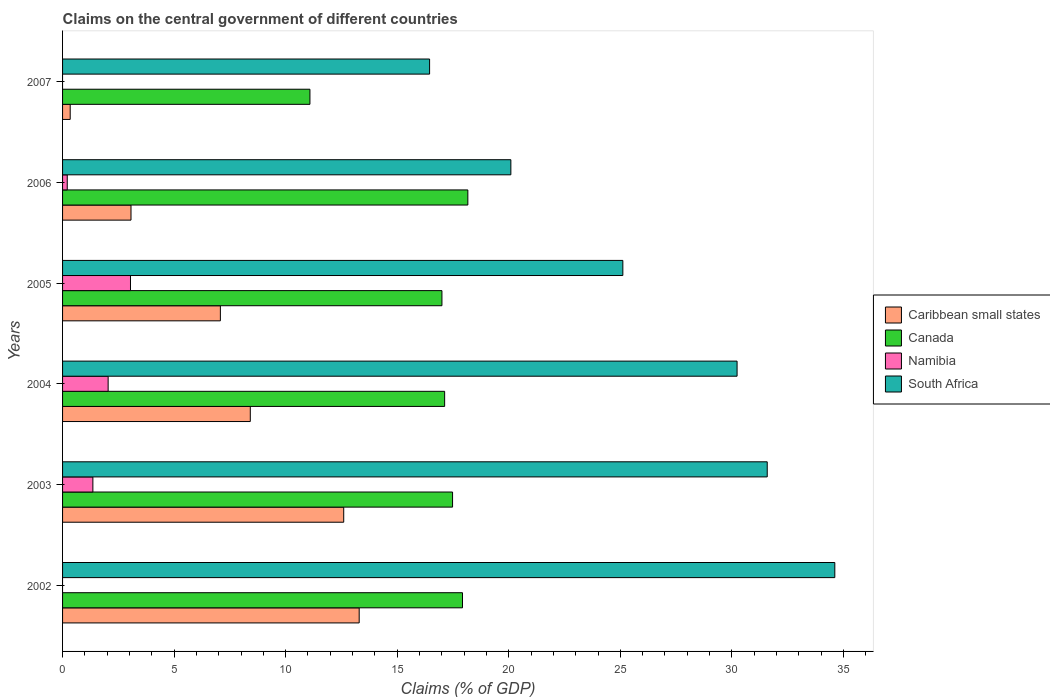Are the number of bars per tick equal to the number of legend labels?
Keep it short and to the point. No. How many bars are there on the 4th tick from the top?
Ensure brevity in your answer.  4. How many bars are there on the 5th tick from the bottom?
Keep it short and to the point. 4. What is the label of the 2nd group of bars from the top?
Offer a terse response. 2006. In how many cases, is the number of bars for a given year not equal to the number of legend labels?
Give a very brief answer. 2. What is the percentage of GDP claimed on the central government in Caribbean small states in 2004?
Keep it short and to the point. 8.41. Across all years, what is the maximum percentage of GDP claimed on the central government in Canada?
Offer a very short reply. 18.17. Across all years, what is the minimum percentage of GDP claimed on the central government in South Africa?
Make the answer very short. 16.45. In which year was the percentage of GDP claimed on the central government in Caribbean small states maximum?
Make the answer very short. 2002. What is the total percentage of GDP claimed on the central government in South Africa in the graph?
Your response must be concise. 158.09. What is the difference between the percentage of GDP claimed on the central government in Caribbean small states in 2004 and that in 2005?
Your answer should be very brief. 1.34. What is the difference between the percentage of GDP claimed on the central government in Namibia in 2005 and the percentage of GDP claimed on the central government in Caribbean small states in 2007?
Give a very brief answer. 2.7. What is the average percentage of GDP claimed on the central government in Namibia per year?
Offer a very short reply. 1.11. In the year 2005, what is the difference between the percentage of GDP claimed on the central government in Namibia and percentage of GDP claimed on the central government in South Africa?
Ensure brevity in your answer.  -22.07. What is the ratio of the percentage of GDP claimed on the central government in South Africa in 2003 to that in 2007?
Provide a short and direct response. 1.92. Is the difference between the percentage of GDP claimed on the central government in Namibia in 2005 and 2006 greater than the difference between the percentage of GDP claimed on the central government in South Africa in 2005 and 2006?
Your answer should be compact. No. What is the difference between the highest and the second highest percentage of GDP claimed on the central government in South Africa?
Make the answer very short. 3.03. What is the difference between the highest and the lowest percentage of GDP claimed on the central government in South Africa?
Give a very brief answer. 18.16. Is it the case that in every year, the sum of the percentage of GDP claimed on the central government in Canada and percentage of GDP claimed on the central government in Namibia is greater than the sum of percentage of GDP claimed on the central government in South Africa and percentage of GDP claimed on the central government in Caribbean small states?
Make the answer very short. No. How many bars are there?
Your answer should be very brief. 22. Does the graph contain any zero values?
Keep it short and to the point. Yes. Does the graph contain grids?
Make the answer very short. No. How many legend labels are there?
Offer a terse response. 4. How are the legend labels stacked?
Provide a succinct answer. Vertical. What is the title of the graph?
Provide a short and direct response. Claims on the central government of different countries. Does "Comoros" appear as one of the legend labels in the graph?
Provide a short and direct response. No. What is the label or title of the X-axis?
Ensure brevity in your answer.  Claims (% of GDP). What is the label or title of the Y-axis?
Offer a terse response. Years. What is the Claims (% of GDP) of Caribbean small states in 2002?
Give a very brief answer. 13.3. What is the Claims (% of GDP) in Canada in 2002?
Make the answer very short. 17.93. What is the Claims (% of GDP) in South Africa in 2002?
Your answer should be very brief. 34.61. What is the Claims (% of GDP) in Caribbean small states in 2003?
Keep it short and to the point. 12.6. What is the Claims (% of GDP) in Canada in 2003?
Your response must be concise. 17.48. What is the Claims (% of GDP) of Namibia in 2003?
Give a very brief answer. 1.36. What is the Claims (% of GDP) in South Africa in 2003?
Give a very brief answer. 31.58. What is the Claims (% of GDP) in Caribbean small states in 2004?
Your answer should be very brief. 8.41. What is the Claims (% of GDP) in Canada in 2004?
Ensure brevity in your answer.  17.13. What is the Claims (% of GDP) of Namibia in 2004?
Make the answer very short. 2.04. What is the Claims (% of GDP) of South Africa in 2004?
Your answer should be compact. 30.23. What is the Claims (% of GDP) of Caribbean small states in 2005?
Provide a short and direct response. 7.07. What is the Claims (% of GDP) of Canada in 2005?
Make the answer very short. 17. What is the Claims (% of GDP) of Namibia in 2005?
Your response must be concise. 3.04. What is the Claims (% of GDP) in South Africa in 2005?
Your answer should be compact. 25.11. What is the Claims (% of GDP) of Caribbean small states in 2006?
Ensure brevity in your answer.  3.07. What is the Claims (% of GDP) in Canada in 2006?
Keep it short and to the point. 18.17. What is the Claims (% of GDP) in Namibia in 2006?
Provide a succinct answer. 0.21. What is the Claims (% of GDP) in South Africa in 2006?
Offer a terse response. 20.09. What is the Claims (% of GDP) in Caribbean small states in 2007?
Give a very brief answer. 0.34. What is the Claims (% of GDP) of Canada in 2007?
Your answer should be compact. 11.09. What is the Claims (% of GDP) of Namibia in 2007?
Your response must be concise. 0. What is the Claims (% of GDP) in South Africa in 2007?
Offer a terse response. 16.45. Across all years, what is the maximum Claims (% of GDP) of Caribbean small states?
Offer a terse response. 13.3. Across all years, what is the maximum Claims (% of GDP) in Canada?
Offer a terse response. 18.17. Across all years, what is the maximum Claims (% of GDP) of Namibia?
Ensure brevity in your answer.  3.04. Across all years, what is the maximum Claims (% of GDP) of South Africa?
Provide a succinct answer. 34.61. Across all years, what is the minimum Claims (% of GDP) of Caribbean small states?
Provide a short and direct response. 0.34. Across all years, what is the minimum Claims (% of GDP) in Canada?
Give a very brief answer. 11.09. Across all years, what is the minimum Claims (% of GDP) in Namibia?
Keep it short and to the point. 0. Across all years, what is the minimum Claims (% of GDP) of South Africa?
Ensure brevity in your answer.  16.45. What is the total Claims (% of GDP) in Caribbean small states in the graph?
Ensure brevity in your answer.  44.79. What is the total Claims (% of GDP) in Canada in the graph?
Give a very brief answer. 98.79. What is the total Claims (% of GDP) in Namibia in the graph?
Keep it short and to the point. 6.65. What is the total Claims (% of GDP) of South Africa in the graph?
Give a very brief answer. 158.09. What is the difference between the Claims (% of GDP) in Caribbean small states in 2002 and that in 2003?
Make the answer very short. 0.69. What is the difference between the Claims (% of GDP) in Canada in 2002 and that in 2003?
Give a very brief answer. 0.45. What is the difference between the Claims (% of GDP) of South Africa in 2002 and that in 2003?
Your answer should be compact. 3.03. What is the difference between the Claims (% of GDP) of Caribbean small states in 2002 and that in 2004?
Your response must be concise. 4.88. What is the difference between the Claims (% of GDP) of Canada in 2002 and that in 2004?
Your answer should be compact. 0.8. What is the difference between the Claims (% of GDP) of South Africa in 2002 and that in 2004?
Offer a terse response. 4.38. What is the difference between the Claims (% of GDP) of Caribbean small states in 2002 and that in 2005?
Your response must be concise. 6.22. What is the difference between the Claims (% of GDP) in Canada in 2002 and that in 2005?
Offer a very short reply. 0.92. What is the difference between the Claims (% of GDP) in South Africa in 2002 and that in 2005?
Offer a terse response. 9.5. What is the difference between the Claims (% of GDP) in Caribbean small states in 2002 and that in 2006?
Offer a very short reply. 10.23. What is the difference between the Claims (% of GDP) of Canada in 2002 and that in 2006?
Offer a very short reply. -0.24. What is the difference between the Claims (% of GDP) in South Africa in 2002 and that in 2006?
Make the answer very short. 14.52. What is the difference between the Claims (% of GDP) of Caribbean small states in 2002 and that in 2007?
Offer a terse response. 12.95. What is the difference between the Claims (% of GDP) in Canada in 2002 and that in 2007?
Provide a succinct answer. 6.84. What is the difference between the Claims (% of GDP) in South Africa in 2002 and that in 2007?
Your response must be concise. 18.16. What is the difference between the Claims (% of GDP) in Caribbean small states in 2003 and that in 2004?
Give a very brief answer. 4.19. What is the difference between the Claims (% of GDP) of Canada in 2003 and that in 2004?
Give a very brief answer. 0.36. What is the difference between the Claims (% of GDP) of Namibia in 2003 and that in 2004?
Ensure brevity in your answer.  -0.68. What is the difference between the Claims (% of GDP) in South Africa in 2003 and that in 2004?
Provide a succinct answer. 1.35. What is the difference between the Claims (% of GDP) in Caribbean small states in 2003 and that in 2005?
Ensure brevity in your answer.  5.53. What is the difference between the Claims (% of GDP) of Canada in 2003 and that in 2005?
Your response must be concise. 0.48. What is the difference between the Claims (% of GDP) in Namibia in 2003 and that in 2005?
Offer a terse response. -1.69. What is the difference between the Claims (% of GDP) of South Africa in 2003 and that in 2005?
Provide a short and direct response. 6.47. What is the difference between the Claims (% of GDP) in Caribbean small states in 2003 and that in 2006?
Offer a terse response. 9.53. What is the difference between the Claims (% of GDP) of Canada in 2003 and that in 2006?
Give a very brief answer. -0.68. What is the difference between the Claims (% of GDP) of Namibia in 2003 and that in 2006?
Provide a succinct answer. 1.15. What is the difference between the Claims (% of GDP) of South Africa in 2003 and that in 2006?
Offer a terse response. 11.49. What is the difference between the Claims (% of GDP) of Caribbean small states in 2003 and that in 2007?
Provide a succinct answer. 12.26. What is the difference between the Claims (% of GDP) of Canada in 2003 and that in 2007?
Offer a very short reply. 6.39. What is the difference between the Claims (% of GDP) of South Africa in 2003 and that in 2007?
Your answer should be compact. 15.13. What is the difference between the Claims (% of GDP) in Caribbean small states in 2004 and that in 2005?
Make the answer very short. 1.34. What is the difference between the Claims (% of GDP) in Canada in 2004 and that in 2005?
Keep it short and to the point. 0.12. What is the difference between the Claims (% of GDP) of Namibia in 2004 and that in 2005?
Make the answer very short. -1. What is the difference between the Claims (% of GDP) of South Africa in 2004 and that in 2005?
Keep it short and to the point. 5.12. What is the difference between the Claims (% of GDP) in Caribbean small states in 2004 and that in 2006?
Ensure brevity in your answer.  5.35. What is the difference between the Claims (% of GDP) of Canada in 2004 and that in 2006?
Provide a succinct answer. -1.04. What is the difference between the Claims (% of GDP) in Namibia in 2004 and that in 2006?
Keep it short and to the point. 1.83. What is the difference between the Claims (% of GDP) of South Africa in 2004 and that in 2006?
Give a very brief answer. 10.14. What is the difference between the Claims (% of GDP) in Caribbean small states in 2004 and that in 2007?
Make the answer very short. 8.07. What is the difference between the Claims (% of GDP) of Canada in 2004 and that in 2007?
Your answer should be very brief. 6.04. What is the difference between the Claims (% of GDP) in South Africa in 2004 and that in 2007?
Your answer should be very brief. 13.78. What is the difference between the Claims (% of GDP) in Caribbean small states in 2005 and that in 2006?
Provide a succinct answer. 4.01. What is the difference between the Claims (% of GDP) in Canada in 2005 and that in 2006?
Ensure brevity in your answer.  -1.16. What is the difference between the Claims (% of GDP) in Namibia in 2005 and that in 2006?
Make the answer very short. 2.83. What is the difference between the Claims (% of GDP) in South Africa in 2005 and that in 2006?
Give a very brief answer. 5.02. What is the difference between the Claims (% of GDP) in Caribbean small states in 2005 and that in 2007?
Your answer should be very brief. 6.73. What is the difference between the Claims (% of GDP) of Canada in 2005 and that in 2007?
Give a very brief answer. 5.92. What is the difference between the Claims (% of GDP) of South Africa in 2005 and that in 2007?
Your response must be concise. 8.66. What is the difference between the Claims (% of GDP) in Caribbean small states in 2006 and that in 2007?
Ensure brevity in your answer.  2.73. What is the difference between the Claims (% of GDP) of Canada in 2006 and that in 2007?
Your answer should be compact. 7.08. What is the difference between the Claims (% of GDP) in South Africa in 2006 and that in 2007?
Make the answer very short. 3.64. What is the difference between the Claims (% of GDP) of Caribbean small states in 2002 and the Claims (% of GDP) of Canada in 2003?
Your response must be concise. -4.19. What is the difference between the Claims (% of GDP) in Caribbean small states in 2002 and the Claims (% of GDP) in Namibia in 2003?
Give a very brief answer. 11.94. What is the difference between the Claims (% of GDP) in Caribbean small states in 2002 and the Claims (% of GDP) in South Africa in 2003?
Keep it short and to the point. -18.29. What is the difference between the Claims (% of GDP) in Canada in 2002 and the Claims (% of GDP) in Namibia in 2003?
Keep it short and to the point. 16.57. What is the difference between the Claims (% of GDP) of Canada in 2002 and the Claims (% of GDP) of South Africa in 2003?
Your answer should be compact. -13.66. What is the difference between the Claims (% of GDP) in Caribbean small states in 2002 and the Claims (% of GDP) in Canada in 2004?
Ensure brevity in your answer.  -3.83. What is the difference between the Claims (% of GDP) of Caribbean small states in 2002 and the Claims (% of GDP) of Namibia in 2004?
Keep it short and to the point. 11.25. What is the difference between the Claims (% of GDP) of Caribbean small states in 2002 and the Claims (% of GDP) of South Africa in 2004?
Make the answer very short. -16.94. What is the difference between the Claims (% of GDP) in Canada in 2002 and the Claims (% of GDP) in Namibia in 2004?
Your answer should be very brief. 15.88. What is the difference between the Claims (% of GDP) in Canada in 2002 and the Claims (% of GDP) in South Africa in 2004?
Your answer should be very brief. -12.31. What is the difference between the Claims (% of GDP) in Caribbean small states in 2002 and the Claims (% of GDP) in Canada in 2005?
Provide a succinct answer. -3.71. What is the difference between the Claims (% of GDP) of Caribbean small states in 2002 and the Claims (% of GDP) of Namibia in 2005?
Provide a succinct answer. 10.25. What is the difference between the Claims (% of GDP) in Caribbean small states in 2002 and the Claims (% of GDP) in South Africa in 2005?
Your answer should be compact. -11.82. What is the difference between the Claims (% of GDP) in Canada in 2002 and the Claims (% of GDP) in Namibia in 2005?
Your answer should be very brief. 14.88. What is the difference between the Claims (% of GDP) in Canada in 2002 and the Claims (% of GDP) in South Africa in 2005?
Make the answer very short. -7.19. What is the difference between the Claims (% of GDP) in Caribbean small states in 2002 and the Claims (% of GDP) in Canada in 2006?
Make the answer very short. -4.87. What is the difference between the Claims (% of GDP) of Caribbean small states in 2002 and the Claims (% of GDP) of Namibia in 2006?
Your response must be concise. 13.09. What is the difference between the Claims (% of GDP) of Caribbean small states in 2002 and the Claims (% of GDP) of South Africa in 2006?
Your response must be concise. -6.8. What is the difference between the Claims (% of GDP) in Canada in 2002 and the Claims (% of GDP) in Namibia in 2006?
Provide a succinct answer. 17.72. What is the difference between the Claims (% of GDP) of Canada in 2002 and the Claims (% of GDP) of South Africa in 2006?
Your answer should be very brief. -2.17. What is the difference between the Claims (% of GDP) of Caribbean small states in 2002 and the Claims (% of GDP) of Canada in 2007?
Offer a terse response. 2.21. What is the difference between the Claims (% of GDP) of Caribbean small states in 2002 and the Claims (% of GDP) of South Africa in 2007?
Provide a succinct answer. -3.16. What is the difference between the Claims (% of GDP) of Canada in 2002 and the Claims (% of GDP) of South Africa in 2007?
Provide a succinct answer. 1.48. What is the difference between the Claims (% of GDP) in Caribbean small states in 2003 and the Claims (% of GDP) in Canada in 2004?
Your answer should be very brief. -4.52. What is the difference between the Claims (% of GDP) of Caribbean small states in 2003 and the Claims (% of GDP) of Namibia in 2004?
Offer a very short reply. 10.56. What is the difference between the Claims (% of GDP) in Caribbean small states in 2003 and the Claims (% of GDP) in South Africa in 2004?
Your response must be concise. -17.63. What is the difference between the Claims (% of GDP) of Canada in 2003 and the Claims (% of GDP) of Namibia in 2004?
Offer a very short reply. 15.44. What is the difference between the Claims (% of GDP) of Canada in 2003 and the Claims (% of GDP) of South Africa in 2004?
Offer a terse response. -12.75. What is the difference between the Claims (% of GDP) in Namibia in 2003 and the Claims (% of GDP) in South Africa in 2004?
Offer a very short reply. -28.88. What is the difference between the Claims (% of GDP) of Caribbean small states in 2003 and the Claims (% of GDP) of Canada in 2005?
Ensure brevity in your answer.  -4.4. What is the difference between the Claims (% of GDP) of Caribbean small states in 2003 and the Claims (% of GDP) of Namibia in 2005?
Provide a short and direct response. 9.56. What is the difference between the Claims (% of GDP) of Caribbean small states in 2003 and the Claims (% of GDP) of South Africa in 2005?
Offer a very short reply. -12.51. What is the difference between the Claims (% of GDP) of Canada in 2003 and the Claims (% of GDP) of Namibia in 2005?
Offer a terse response. 14.44. What is the difference between the Claims (% of GDP) of Canada in 2003 and the Claims (% of GDP) of South Africa in 2005?
Your answer should be very brief. -7.63. What is the difference between the Claims (% of GDP) in Namibia in 2003 and the Claims (% of GDP) in South Africa in 2005?
Offer a terse response. -23.75. What is the difference between the Claims (% of GDP) in Caribbean small states in 2003 and the Claims (% of GDP) in Canada in 2006?
Offer a terse response. -5.56. What is the difference between the Claims (% of GDP) of Caribbean small states in 2003 and the Claims (% of GDP) of Namibia in 2006?
Ensure brevity in your answer.  12.39. What is the difference between the Claims (% of GDP) of Caribbean small states in 2003 and the Claims (% of GDP) of South Africa in 2006?
Offer a very short reply. -7.49. What is the difference between the Claims (% of GDP) of Canada in 2003 and the Claims (% of GDP) of Namibia in 2006?
Give a very brief answer. 17.27. What is the difference between the Claims (% of GDP) of Canada in 2003 and the Claims (% of GDP) of South Africa in 2006?
Your answer should be very brief. -2.61. What is the difference between the Claims (% of GDP) in Namibia in 2003 and the Claims (% of GDP) in South Africa in 2006?
Provide a short and direct response. -18.74. What is the difference between the Claims (% of GDP) of Caribbean small states in 2003 and the Claims (% of GDP) of Canada in 2007?
Give a very brief answer. 1.51. What is the difference between the Claims (% of GDP) of Caribbean small states in 2003 and the Claims (% of GDP) of South Africa in 2007?
Make the answer very short. -3.85. What is the difference between the Claims (% of GDP) in Canada in 2003 and the Claims (% of GDP) in South Africa in 2007?
Make the answer very short. 1.03. What is the difference between the Claims (% of GDP) of Namibia in 2003 and the Claims (% of GDP) of South Africa in 2007?
Make the answer very short. -15.09. What is the difference between the Claims (% of GDP) in Caribbean small states in 2004 and the Claims (% of GDP) in Canada in 2005?
Provide a succinct answer. -8.59. What is the difference between the Claims (% of GDP) of Caribbean small states in 2004 and the Claims (% of GDP) of Namibia in 2005?
Your response must be concise. 5.37. What is the difference between the Claims (% of GDP) in Caribbean small states in 2004 and the Claims (% of GDP) in South Africa in 2005?
Your answer should be compact. -16.7. What is the difference between the Claims (% of GDP) of Canada in 2004 and the Claims (% of GDP) of Namibia in 2005?
Offer a terse response. 14.08. What is the difference between the Claims (% of GDP) in Canada in 2004 and the Claims (% of GDP) in South Africa in 2005?
Your answer should be very brief. -7.99. What is the difference between the Claims (% of GDP) in Namibia in 2004 and the Claims (% of GDP) in South Africa in 2005?
Keep it short and to the point. -23.07. What is the difference between the Claims (% of GDP) in Caribbean small states in 2004 and the Claims (% of GDP) in Canada in 2006?
Your response must be concise. -9.75. What is the difference between the Claims (% of GDP) of Caribbean small states in 2004 and the Claims (% of GDP) of Namibia in 2006?
Your answer should be compact. 8.2. What is the difference between the Claims (% of GDP) in Caribbean small states in 2004 and the Claims (% of GDP) in South Africa in 2006?
Ensure brevity in your answer.  -11.68. What is the difference between the Claims (% of GDP) in Canada in 2004 and the Claims (% of GDP) in Namibia in 2006?
Offer a terse response. 16.92. What is the difference between the Claims (% of GDP) of Canada in 2004 and the Claims (% of GDP) of South Africa in 2006?
Keep it short and to the point. -2.97. What is the difference between the Claims (% of GDP) in Namibia in 2004 and the Claims (% of GDP) in South Africa in 2006?
Keep it short and to the point. -18.05. What is the difference between the Claims (% of GDP) in Caribbean small states in 2004 and the Claims (% of GDP) in Canada in 2007?
Provide a succinct answer. -2.67. What is the difference between the Claims (% of GDP) in Caribbean small states in 2004 and the Claims (% of GDP) in South Africa in 2007?
Your response must be concise. -8.04. What is the difference between the Claims (% of GDP) of Canada in 2004 and the Claims (% of GDP) of South Africa in 2007?
Offer a very short reply. 0.67. What is the difference between the Claims (% of GDP) in Namibia in 2004 and the Claims (% of GDP) in South Africa in 2007?
Keep it short and to the point. -14.41. What is the difference between the Claims (% of GDP) of Caribbean small states in 2005 and the Claims (% of GDP) of Canada in 2006?
Keep it short and to the point. -11.09. What is the difference between the Claims (% of GDP) of Caribbean small states in 2005 and the Claims (% of GDP) of Namibia in 2006?
Ensure brevity in your answer.  6.86. What is the difference between the Claims (% of GDP) in Caribbean small states in 2005 and the Claims (% of GDP) in South Africa in 2006?
Provide a short and direct response. -13.02. What is the difference between the Claims (% of GDP) of Canada in 2005 and the Claims (% of GDP) of Namibia in 2006?
Your answer should be very brief. 16.79. What is the difference between the Claims (% of GDP) of Canada in 2005 and the Claims (% of GDP) of South Africa in 2006?
Your response must be concise. -3.09. What is the difference between the Claims (% of GDP) of Namibia in 2005 and the Claims (% of GDP) of South Africa in 2006?
Your answer should be very brief. -17.05. What is the difference between the Claims (% of GDP) in Caribbean small states in 2005 and the Claims (% of GDP) in Canada in 2007?
Keep it short and to the point. -4.01. What is the difference between the Claims (% of GDP) of Caribbean small states in 2005 and the Claims (% of GDP) of South Africa in 2007?
Make the answer very short. -9.38. What is the difference between the Claims (% of GDP) in Canada in 2005 and the Claims (% of GDP) in South Africa in 2007?
Your answer should be compact. 0.55. What is the difference between the Claims (% of GDP) in Namibia in 2005 and the Claims (% of GDP) in South Africa in 2007?
Provide a succinct answer. -13.41. What is the difference between the Claims (% of GDP) in Caribbean small states in 2006 and the Claims (% of GDP) in Canada in 2007?
Make the answer very short. -8.02. What is the difference between the Claims (% of GDP) in Caribbean small states in 2006 and the Claims (% of GDP) in South Africa in 2007?
Offer a terse response. -13.38. What is the difference between the Claims (% of GDP) in Canada in 2006 and the Claims (% of GDP) in South Africa in 2007?
Offer a terse response. 1.71. What is the difference between the Claims (% of GDP) of Namibia in 2006 and the Claims (% of GDP) of South Africa in 2007?
Provide a short and direct response. -16.24. What is the average Claims (% of GDP) of Caribbean small states per year?
Your answer should be compact. 7.47. What is the average Claims (% of GDP) in Canada per year?
Your answer should be compact. 16.46. What is the average Claims (% of GDP) of Namibia per year?
Give a very brief answer. 1.11. What is the average Claims (% of GDP) in South Africa per year?
Make the answer very short. 26.35. In the year 2002, what is the difference between the Claims (% of GDP) of Caribbean small states and Claims (% of GDP) of Canada?
Your answer should be very brief. -4.63. In the year 2002, what is the difference between the Claims (% of GDP) of Caribbean small states and Claims (% of GDP) of South Africa?
Your answer should be very brief. -21.32. In the year 2002, what is the difference between the Claims (% of GDP) in Canada and Claims (% of GDP) in South Africa?
Provide a succinct answer. -16.69. In the year 2003, what is the difference between the Claims (% of GDP) of Caribbean small states and Claims (% of GDP) of Canada?
Your answer should be very brief. -4.88. In the year 2003, what is the difference between the Claims (% of GDP) of Caribbean small states and Claims (% of GDP) of Namibia?
Provide a short and direct response. 11.24. In the year 2003, what is the difference between the Claims (% of GDP) in Caribbean small states and Claims (% of GDP) in South Africa?
Your response must be concise. -18.98. In the year 2003, what is the difference between the Claims (% of GDP) in Canada and Claims (% of GDP) in Namibia?
Your response must be concise. 16.12. In the year 2003, what is the difference between the Claims (% of GDP) in Canada and Claims (% of GDP) in South Africa?
Your answer should be compact. -14.1. In the year 2003, what is the difference between the Claims (% of GDP) of Namibia and Claims (% of GDP) of South Africa?
Provide a succinct answer. -30.23. In the year 2004, what is the difference between the Claims (% of GDP) in Caribbean small states and Claims (% of GDP) in Canada?
Provide a short and direct response. -8.71. In the year 2004, what is the difference between the Claims (% of GDP) in Caribbean small states and Claims (% of GDP) in Namibia?
Your answer should be very brief. 6.37. In the year 2004, what is the difference between the Claims (% of GDP) of Caribbean small states and Claims (% of GDP) of South Africa?
Provide a succinct answer. -21.82. In the year 2004, what is the difference between the Claims (% of GDP) of Canada and Claims (% of GDP) of Namibia?
Your response must be concise. 15.08. In the year 2004, what is the difference between the Claims (% of GDP) of Canada and Claims (% of GDP) of South Africa?
Offer a very short reply. -13.11. In the year 2004, what is the difference between the Claims (% of GDP) in Namibia and Claims (% of GDP) in South Africa?
Provide a succinct answer. -28.19. In the year 2005, what is the difference between the Claims (% of GDP) in Caribbean small states and Claims (% of GDP) in Canada?
Your answer should be compact. -9.93. In the year 2005, what is the difference between the Claims (% of GDP) in Caribbean small states and Claims (% of GDP) in Namibia?
Your answer should be compact. 4.03. In the year 2005, what is the difference between the Claims (% of GDP) in Caribbean small states and Claims (% of GDP) in South Africa?
Offer a very short reply. -18.04. In the year 2005, what is the difference between the Claims (% of GDP) of Canada and Claims (% of GDP) of Namibia?
Ensure brevity in your answer.  13.96. In the year 2005, what is the difference between the Claims (% of GDP) in Canada and Claims (% of GDP) in South Africa?
Keep it short and to the point. -8.11. In the year 2005, what is the difference between the Claims (% of GDP) in Namibia and Claims (% of GDP) in South Africa?
Offer a terse response. -22.07. In the year 2006, what is the difference between the Claims (% of GDP) of Caribbean small states and Claims (% of GDP) of Canada?
Your answer should be compact. -15.1. In the year 2006, what is the difference between the Claims (% of GDP) in Caribbean small states and Claims (% of GDP) in Namibia?
Provide a short and direct response. 2.86. In the year 2006, what is the difference between the Claims (% of GDP) of Caribbean small states and Claims (% of GDP) of South Africa?
Offer a terse response. -17.03. In the year 2006, what is the difference between the Claims (% of GDP) of Canada and Claims (% of GDP) of Namibia?
Provide a succinct answer. 17.96. In the year 2006, what is the difference between the Claims (% of GDP) in Canada and Claims (% of GDP) in South Africa?
Your answer should be very brief. -1.93. In the year 2006, what is the difference between the Claims (% of GDP) of Namibia and Claims (% of GDP) of South Africa?
Ensure brevity in your answer.  -19.88. In the year 2007, what is the difference between the Claims (% of GDP) of Caribbean small states and Claims (% of GDP) of Canada?
Your response must be concise. -10.75. In the year 2007, what is the difference between the Claims (% of GDP) of Caribbean small states and Claims (% of GDP) of South Africa?
Your answer should be very brief. -16.11. In the year 2007, what is the difference between the Claims (% of GDP) of Canada and Claims (% of GDP) of South Africa?
Offer a very short reply. -5.36. What is the ratio of the Claims (% of GDP) of Caribbean small states in 2002 to that in 2003?
Keep it short and to the point. 1.05. What is the ratio of the Claims (% of GDP) in Canada in 2002 to that in 2003?
Ensure brevity in your answer.  1.03. What is the ratio of the Claims (% of GDP) of South Africa in 2002 to that in 2003?
Give a very brief answer. 1.1. What is the ratio of the Claims (% of GDP) of Caribbean small states in 2002 to that in 2004?
Keep it short and to the point. 1.58. What is the ratio of the Claims (% of GDP) in Canada in 2002 to that in 2004?
Ensure brevity in your answer.  1.05. What is the ratio of the Claims (% of GDP) in South Africa in 2002 to that in 2004?
Your answer should be compact. 1.14. What is the ratio of the Claims (% of GDP) in Caribbean small states in 2002 to that in 2005?
Make the answer very short. 1.88. What is the ratio of the Claims (% of GDP) in Canada in 2002 to that in 2005?
Ensure brevity in your answer.  1.05. What is the ratio of the Claims (% of GDP) of South Africa in 2002 to that in 2005?
Your answer should be compact. 1.38. What is the ratio of the Claims (% of GDP) of Caribbean small states in 2002 to that in 2006?
Your response must be concise. 4.33. What is the ratio of the Claims (% of GDP) of South Africa in 2002 to that in 2006?
Provide a short and direct response. 1.72. What is the ratio of the Claims (% of GDP) in Caribbean small states in 2002 to that in 2007?
Make the answer very short. 38.85. What is the ratio of the Claims (% of GDP) in Canada in 2002 to that in 2007?
Keep it short and to the point. 1.62. What is the ratio of the Claims (% of GDP) in South Africa in 2002 to that in 2007?
Ensure brevity in your answer.  2.1. What is the ratio of the Claims (% of GDP) in Caribbean small states in 2003 to that in 2004?
Your response must be concise. 1.5. What is the ratio of the Claims (% of GDP) of Canada in 2003 to that in 2004?
Provide a succinct answer. 1.02. What is the ratio of the Claims (% of GDP) of Namibia in 2003 to that in 2004?
Keep it short and to the point. 0.67. What is the ratio of the Claims (% of GDP) in South Africa in 2003 to that in 2004?
Your answer should be very brief. 1.04. What is the ratio of the Claims (% of GDP) of Caribbean small states in 2003 to that in 2005?
Provide a short and direct response. 1.78. What is the ratio of the Claims (% of GDP) of Canada in 2003 to that in 2005?
Provide a short and direct response. 1.03. What is the ratio of the Claims (% of GDP) of Namibia in 2003 to that in 2005?
Your response must be concise. 0.45. What is the ratio of the Claims (% of GDP) of South Africa in 2003 to that in 2005?
Keep it short and to the point. 1.26. What is the ratio of the Claims (% of GDP) in Caribbean small states in 2003 to that in 2006?
Offer a very short reply. 4.11. What is the ratio of the Claims (% of GDP) in Canada in 2003 to that in 2006?
Your answer should be compact. 0.96. What is the ratio of the Claims (% of GDP) in Namibia in 2003 to that in 2006?
Keep it short and to the point. 6.48. What is the ratio of the Claims (% of GDP) of South Africa in 2003 to that in 2006?
Ensure brevity in your answer.  1.57. What is the ratio of the Claims (% of GDP) of Caribbean small states in 2003 to that in 2007?
Offer a terse response. 36.83. What is the ratio of the Claims (% of GDP) in Canada in 2003 to that in 2007?
Your response must be concise. 1.58. What is the ratio of the Claims (% of GDP) of South Africa in 2003 to that in 2007?
Offer a very short reply. 1.92. What is the ratio of the Claims (% of GDP) of Caribbean small states in 2004 to that in 2005?
Give a very brief answer. 1.19. What is the ratio of the Claims (% of GDP) of Canada in 2004 to that in 2005?
Your response must be concise. 1.01. What is the ratio of the Claims (% of GDP) of Namibia in 2004 to that in 2005?
Offer a terse response. 0.67. What is the ratio of the Claims (% of GDP) in South Africa in 2004 to that in 2005?
Provide a succinct answer. 1.2. What is the ratio of the Claims (% of GDP) of Caribbean small states in 2004 to that in 2006?
Your response must be concise. 2.74. What is the ratio of the Claims (% of GDP) in Canada in 2004 to that in 2006?
Give a very brief answer. 0.94. What is the ratio of the Claims (% of GDP) in Namibia in 2004 to that in 2006?
Make the answer very short. 9.74. What is the ratio of the Claims (% of GDP) in South Africa in 2004 to that in 2006?
Ensure brevity in your answer.  1.5. What is the ratio of the Claims (% of GDP) in Caribbean small states in 2004 to that in 2007?
Make the answer very short. 24.59. What is the ratio of the Claims (% of GDP) in Canada in 2004 to that in 2007?
Provide a short and direct response. 1.54. What is the ratio of the Claims (% of GDP) of South Africa in 2004 to that in 2007?
Your answer should be compact. 1.84. What is the ratio of the Claims (% of GDP) in Caribbean small states in 2005 to that in 2006?
Your answer should be very brief. 2.31. What is the ratio of the Claims (% of GDP) of Canada in 2005 to that in 2006?
Provide a succinct answer. 0.94. What is the ratio of the Claims (% of GDP) in Namibia in 2005 to that in 2006?
Provide a short and direct response. 14.51. What is the ratio of the Claims (% of GDP) in South Africa in 2005 to that in 2006?
Your answer should be compact. 1.25. What is the ratio of the Claims (% of GDP) in Caribbean small states in 2005 to that in 2007?
Ensure brevity in your answer.  20.67. What is the ratio of the Claims (% of GDP) in Canada in 2005 to that in 2007?
Keep it short and to the point. 1.53. What is the ratio of the Claims (% of GDP) of South Africa in 2005 to that in 2007?
Offer a terse response. 1.53. What is the ratio of the Claims (% of GDP) in Caribbean small states in 2006 to that in 2007?
Provide a short and direct response. 8.96. What is the ratio of the Claims (% of GDP) of Canada in 2006 to that in 2007?
Provide a succinct answer. 1.64. What is the ratio of the Claims (% of GDP) of South Africa in 2006 to that in 2007?
Provide a short and direct response. 1.22. What is the difference between the highest and the second highest Claims (% of GDP) of Caribbean small states?
Offer a very short reply. 0.69. What is the difference between the highest and the second highest Claims (% of GDP) of Canada?
Provide a succinct answer. 0.24. What is the difference between the highest and the second highest Claims (% of GDP) in Namibia?
Make the answer very short. 1. What is the difference between the highest and the second highest Claims (% of GDP) of South Africa?
Ensure brevity in your answer.  3.03. What is the difference between the highest and the lowest Claims (% of GDP) in Caribbean small states?
Provide a succinct answer. 12.95. What is the difference between the highest and the lowest Claims (% of GDP) in Canada?
Keep it short and to the point. 7.08. What is the difference between the highest and the lowest Claims (% of GDP) in Namibia?
Ensure brevity in your answer.  3.04. What is the difference between the highest and the lowest Claims (% of GDP) in South Africa?
Your response must be concise. 18.16. 